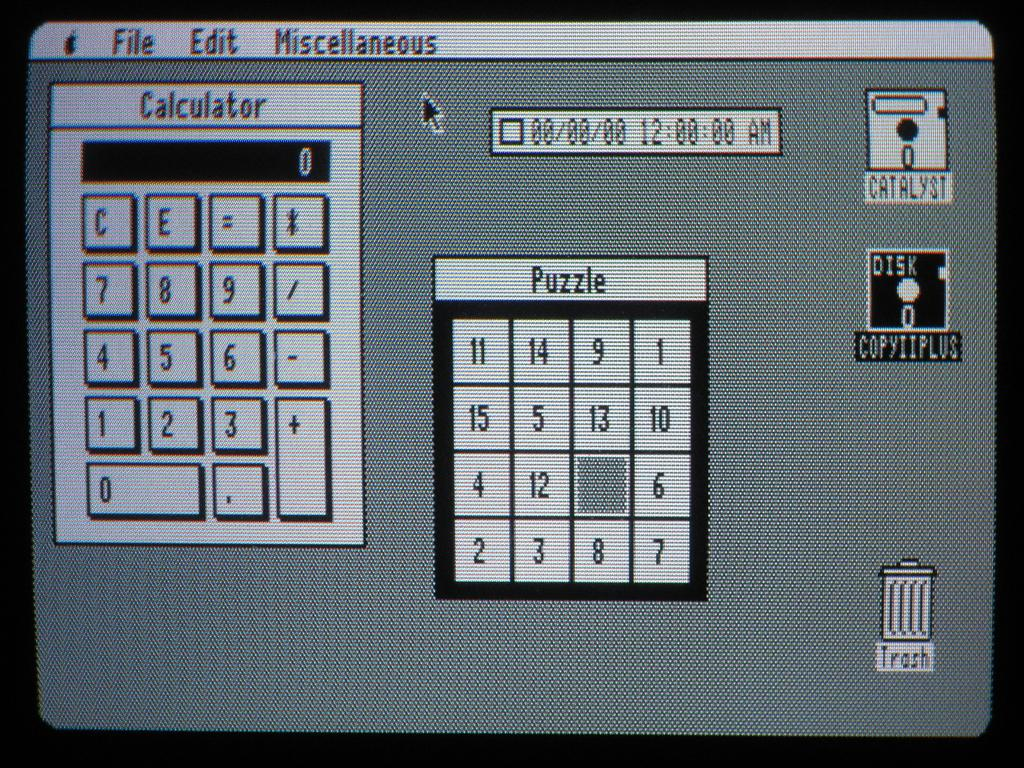<image>
Summarize the visual content of the image. an old computer screen icon list for Calculator, Puzzle and Trash 